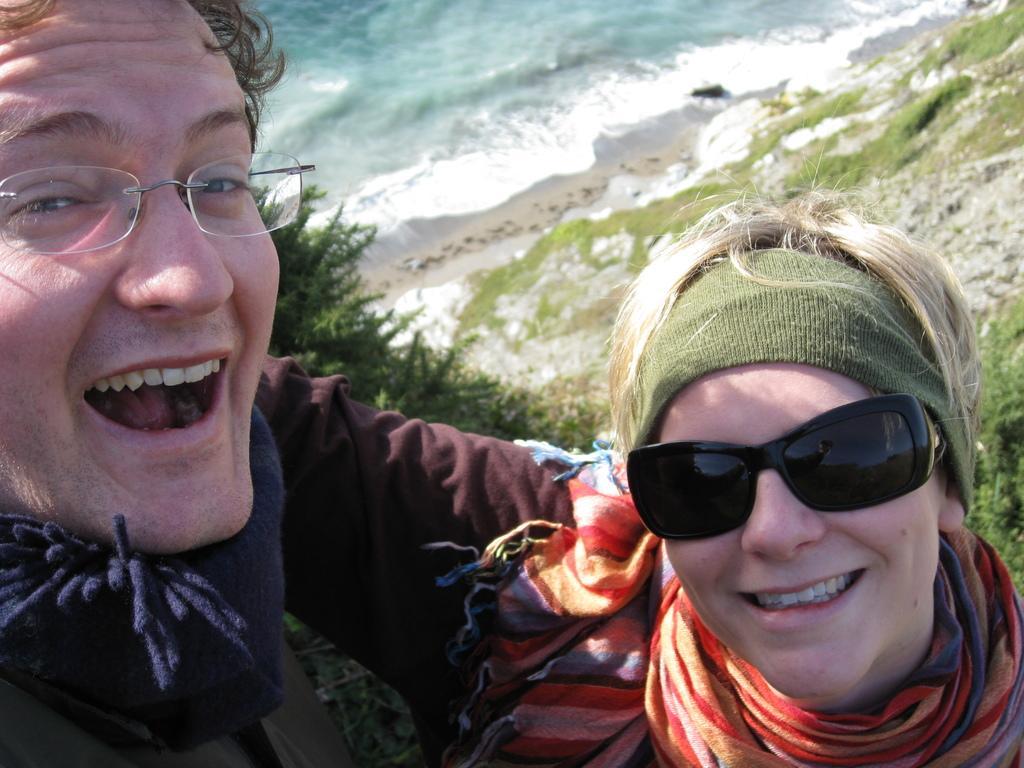Describe this image in one or two sentences. In this picture we can see two persons are smiling in the front, on the left side there is a tree, in the background we can see water, there are some plants on the right side. 